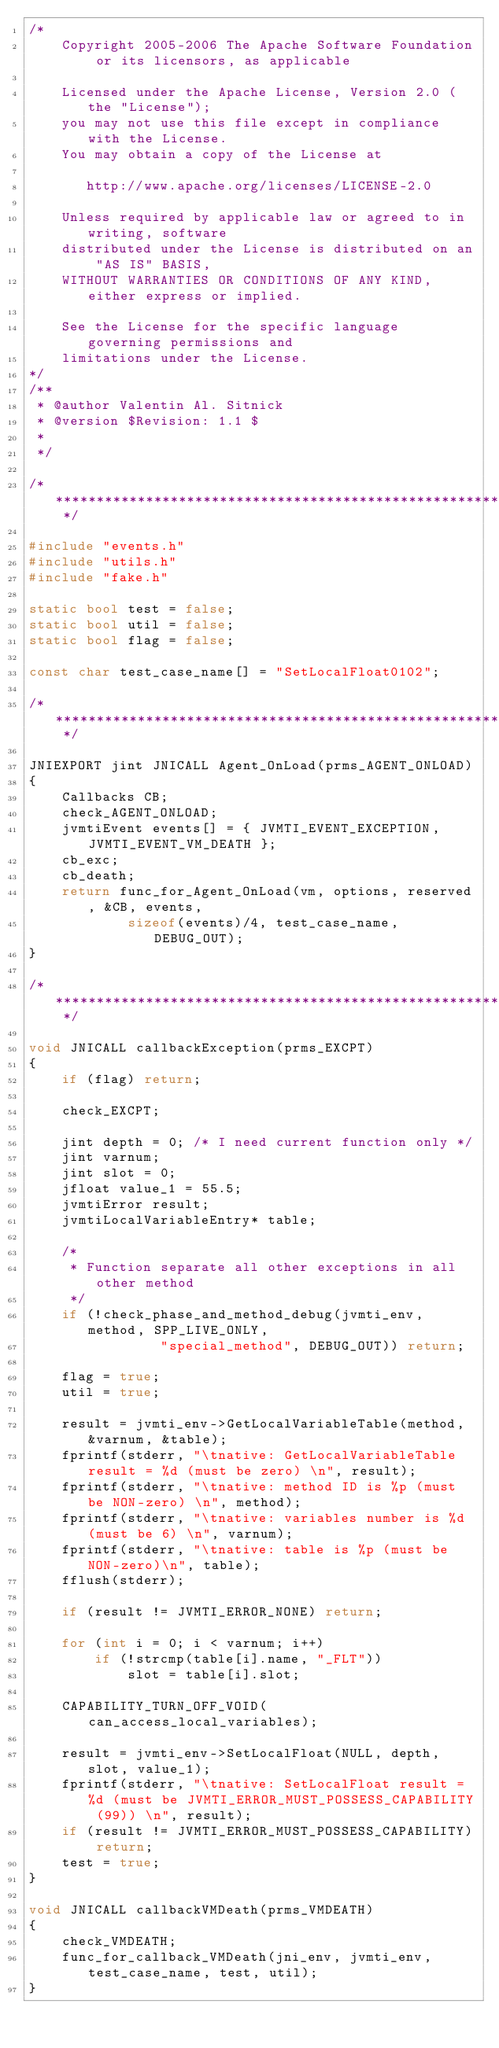Convert code to text. <code><loc_0><loc_0><loc_500><loc_500><_C++_>/*
    Copyright 2005-2006 The Apache Software Foundation or its licensors, as applicable

    Licensed under the Apache License, Version 2.0 (the "License");
    you may not use this file except in compliance with the License.
    You may obtain a copy of the License at

       http://www.apache.org/licenses/LICENSE-2.0

    Unless required by applicable law or agreed to in writing, software
    distributed under the License is distributed on an "AS IS" BASIS,
    WITHOUT WARRANTIES OR CONDITIONS OF ANY KIND, either express or implied.

    See the License for the specific language governing permissions and
    limitations under the License.
*/
/**
 * @author Valentin Al. Sitnick
 * @version $Revision: 1.1 $
 *
 */

/* *********************************************************************** */

#include "events.h"
#include "utils.h"
#include "fake.h"

static bool test = false;
static bool util = false;
static bool flag = false;

const char test_case_name[] = "SetLocalFloat0102";

/* *********************************************************************** */

JNIEXPORT jint JNICALL Agent_OnLoad(prms_AGENT_ONLOAD)
{
    Callbacks CB;
    check_AGENT_ONLOAD;
    jvmtiEvent events[] = { JVMTI_EVENT_EXCEPTION, JVMTI_EVENT_VM_DEATH };
    cb_exc;
    cb_death;
    return func_for_Agent_OnLoad(vm, options, reserved, &CB, events,
            sizeof(events)/4, test_case_name, DEBUG_OUT);
}

/* *********************************************************************** */

void JNICALL callbackException(prms_EXCPT)
{
    if (flag) return;

    check_EXCPT;

    jint depth = 0; /* I need current function only */
    jint varnum;
    jint slot = 0;
    jfloat value_1 = 55.5;
    jvmtiError result;
    jvmtiLocalVariableEntry* table;

    /*
     * Function separate all other exceptions in all other method
     */
    if (!check_phase_and_method_debug(jvmti_env, method, SPP_LIVE_ONLY,
                "special_method", DEBUG_OUT)) return;

    flag = true;
    util = true;

    result = jvmti_env->GetLocalVariableTable(method, &varnum, &table);
    fprintf(stderr, "\tnative: GetLocalVariableTable result = %d (must be zero) \n", result);
    fprintf(stderr, "\tnative: method ID is %p (must be NON-zero) \n", method);
    fprintf(stderr, "\tnative: variables number is %d (must be 6) \n", varnum);
    fprintf(stderr, "\tnative: table is %p (must be NON-zero)\n", table);
    fflush(stderr);

    if (result != JVMTI_ERROR_NONE) return;

    for (int i = 0; i < varnum; i++)
        if (!strcmp(table[i].name, "_FLT"))
            slot = table[i].slot;

    CAPABILITY_TURN_OFF_VOID(can_access_local_variables);

    result = jvmti_env->SetLocalFloat(NULL, depth, slot, value_1);
    fprintf(stderr, "\tnative: SetLocalFloat result = %d (must be JVMTI_ERROR_MUST_POSSESS_CAPABILITY (99)) \n", result);
    if (result != JVMTI_ERROR_MUST_POSSESS_CAPABILITY) return;
    test = true;
}

void JNICALL callbackVMDeath(prms_VMDEATH)
{
    check_VMDEATH;
    func_for_callback_VMDeath(jni_env, jvmti_env, test_case_name, test, util);
}
</code> 